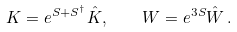<formula> <loc_0><loc_0><loc_500><loc_500>K = e ^ { S + S ^ { \dagger } } \hat { K } , \quad W = e ^ { 3 S } \hat { W } \, .</formula> 